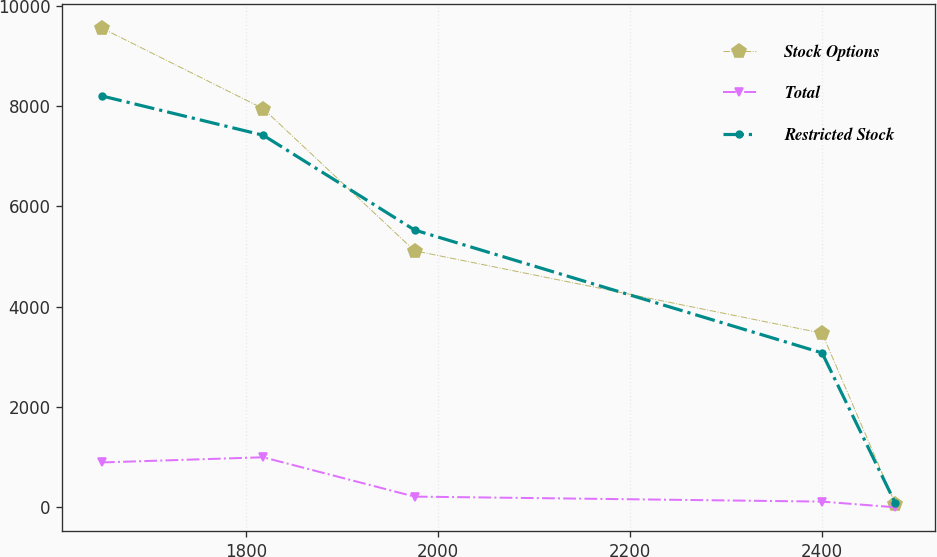Convert chart to OTSL. <chart><loc_0><loc_0><loc_500><loc_500><line_chart><ecel><fcel>Stock Options<fcel>Total<fcel>Restricted Stock<nl><fcel>1649.65<fcel>9556.75<fcel>894.09<fcel>8203.47<nl><fcel>1817.66<fcel>7950.91<fcel>997.32<fcel>7420.4<nl><fcel>1975.31<fcel>5116.3<fcel>212.83<fcel>5530.84<nl><fcel>2399.89<fcel>3472.29<fcel>113.1<fcel>3079.11<nl><fcel>2476.18<fcel>68.2<fcel>0<fcel>82.77<nl></chart> 